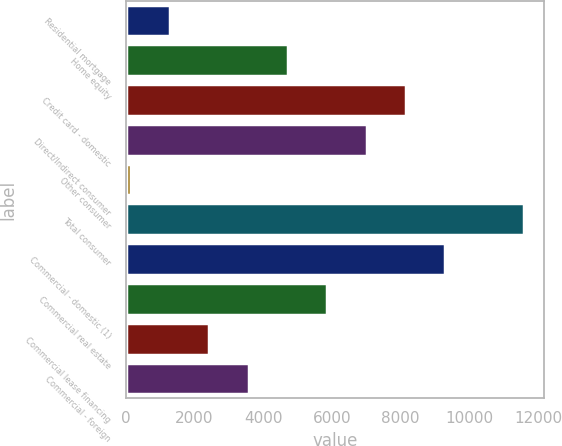Convert chart. <chart><loc_0><loc_0><loc_500><loc_500><bar_chart><fcel>Residential mortgage<fcel>Home equity<fcel>Credit card - domestic<fcel>Direct/Indirect consumer<fcel>Other consumer<fcel>Total consumer<fcel>Commercial - domestic (1)<fcel>Commercial real estate<fcel>Commercial lease financing<fcel>Commercial - foreign<nl><fcel>1294.7<fcel>4725.8<fcel>8156.9<fcel>7013.2<fcel>151<fcel>11588<fcel>9300.6<fcel>5869.5<fcel>2438.4<fcel>3582.1<nl></chart> 